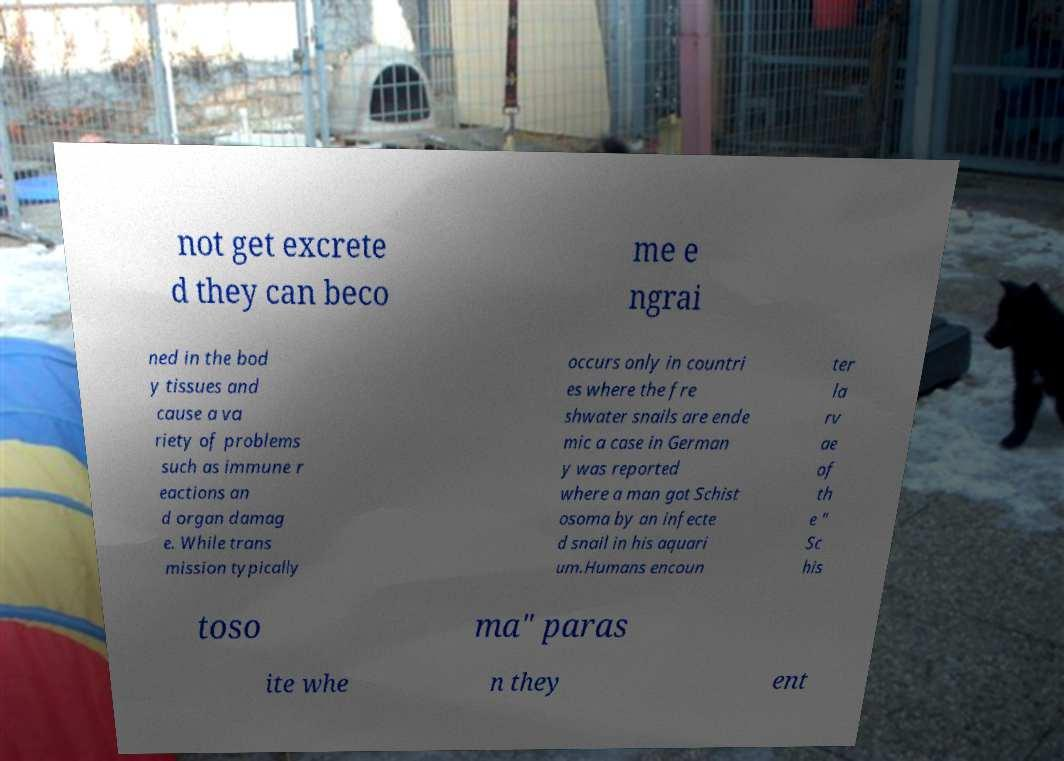Can you read and provide the text displayed in the image?This photo seems to have some interesting text. Can you extract and type it out for me? not get excrete d they can beco me e ngrai ned in the bod y tissues and cause a va riety of problems such as immune r eactions an d organ damag e. While trans mission typically occurs only in countri es where the fre shwater snails are ende mic a case in German y was reported where a man got Schist osoma by an infecte d snail in his aquari um.Humans encoun ter la rv ae of th e " Sc his toso ma" paras ite whe n they ent 